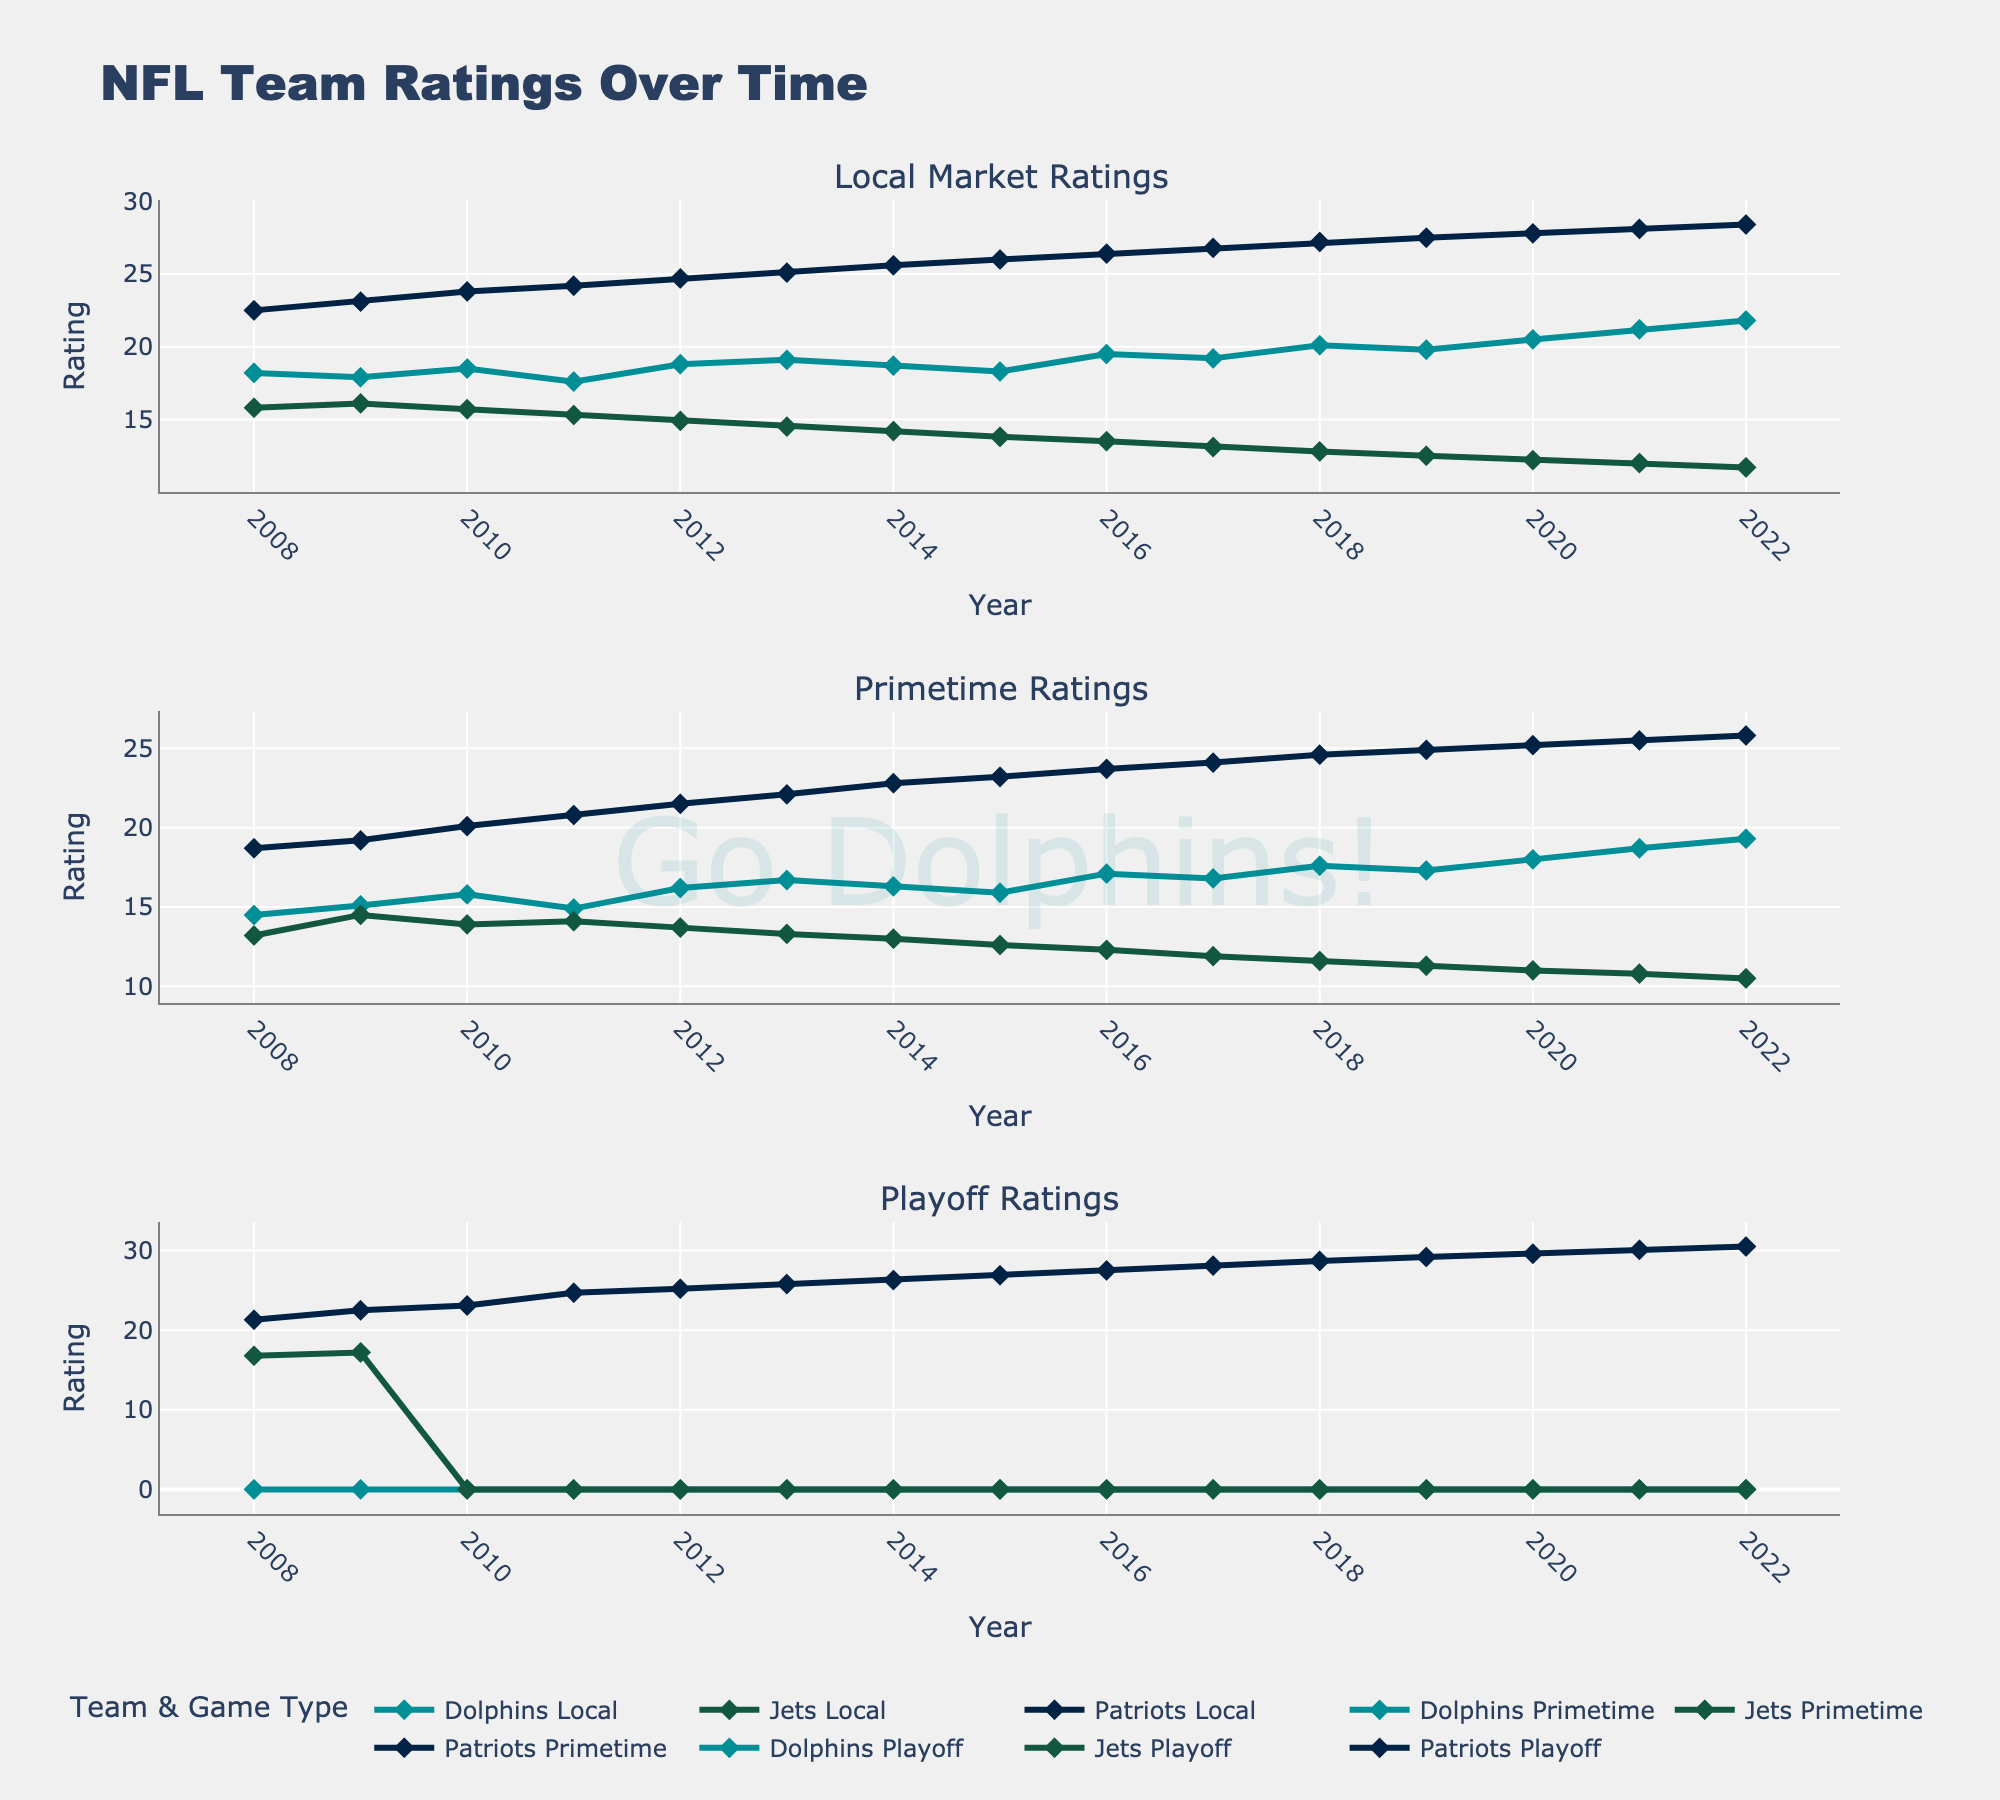Which team's local market ratings have consistently increased over the last 15 years? Over the last 15 years, the chart shows a continuous upward trend in local market ratings for the Dolphins.
Answer: Dolphins In which year did the Patriots have the highest primetime rating? Look at the primetime ratings for the Patriots and find the year with the highest value. The highest primetime rating for the Patriots is around 2022.
Answer: 2022 How do the local market ratings of the Dolphins compare to the Jets in 2022? Compare the local market ratings for the Dolphins and Jets in 2022. The Dolphins have a rating of 21.8 while the Jets have 11.7.
Answer: Dolphins have the higher rating What is the difference between the Dolphins' and Patriots' local market ratings in 2015? Subtract the Patriots' local market rating from the Dolphins' local market rating for 2015. The difference is 18.3 - 26.0.
Answer: -7.7 Which team had the lowest playoff ratings in 2010? Look at the playoff ratings for all three teams in 2010. Only the Patriots had a non-zero playoff rating.
Answer: Patriots How did the Dolphins' primetime rating change between 2010 and 2012? Compare the Dolphins' primetime ratings for 2010 and 2012. The rating increased from 15.8 to 16.2.
Answer: Increased In which year did the Dolphins' local market rating surpass 20? Identify the first year where the Dolphins' local market rating is above 20. This occurs in 2018.
Answer: 2018 What is the average local market rating for the Jets from 2008 to 2022? Sum up the Jets' local market ratings from 2008 to 2022 and divide by the number of years (15). (15.8 + 16.1 + 15.7 + 15.3 + 14.9 + 14.5 + 14.2 + 13.8 + 13.5 + 13.1 + 12.8 + 12.5 + 12.2 + 12.0 + 11.7) / 15 = 14.0
Answer: 14.0 How did the Patriots' primetime ratings change from the start to the end of the period? Compare the Patriots' primetime ratings from 2008 to 2022. The rating increased from 18.7 to 25.8.
Answer: Increased Which team had the steepest decline in local market ratings between 2008 and 2022? Compare the difference in local market ratings from 2008 to 2022 for all three teams. The Jets had the steepest decline from 15.8 to 11.7.
Answer: Jets Which team consistently had the highest playoff ratings? Look at the playoff ratings across the years for all three teams. The Patriots consistently had the highest playoff ratings.
Answer: Patriots 